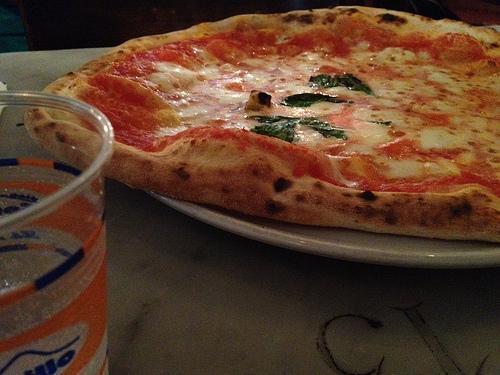How many cups are there?
Give a very brief answer. 1. 